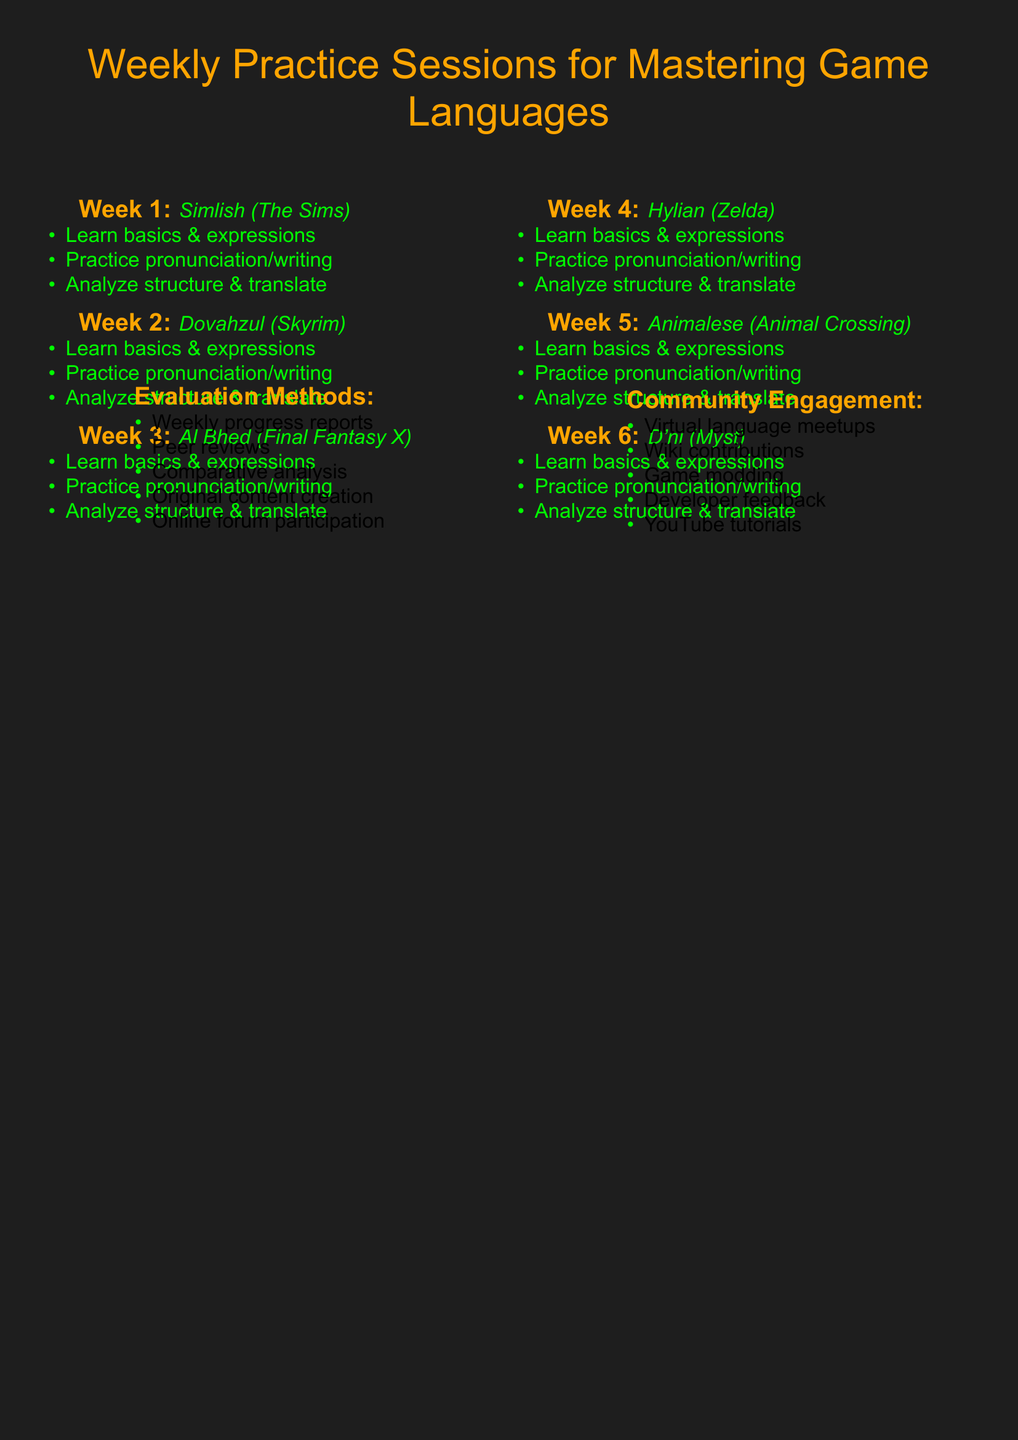What is the focus of week 1? Week 1 focuses on learning Simlish from The Sims series.
Answer: Simlish from The Sims series How many weeks are dedicated to practicing constructed languages? The document lists six weeks of practice sessions for different constructed languages.
Answer: 6 What is one activity listed for week 3? In week 3, one activity is to practice decoding Al Bhed messages from game screenshots.
Answer: Practice decoding Al Bhed messages from game screenshots Which game is associated with the D'ni language? The D'ni language is associated with the Myst series.
Answer: Myst series What is one resource provided for learning Hylian? One resource for learning Hylian is The Legend of Zelda: Breath of the Wild.
Answer: The Legend of Zelda: Breath of the Wild What kind of community engagement is suggested? Organizing virtual language exchange meetups for gamers is one type of community engagement suggested.
Answer: Virtual language exchange meetups What is the purpose of weekly progress reports? Weekly progress reports are to assess language proficiency over time.
Answer: Assess language proficiency What language will be learned in week 5? In week 5, Animalese from the Animal Crossing series will be learned.
Answer: Animalese from Animal Crossing series What is a method for evaluation mentioned in the document? A method for evaluation mentioned is peer reviews of pronunciation and writing skills.
Answer: Peer reviews of pronunciation and writing skills 